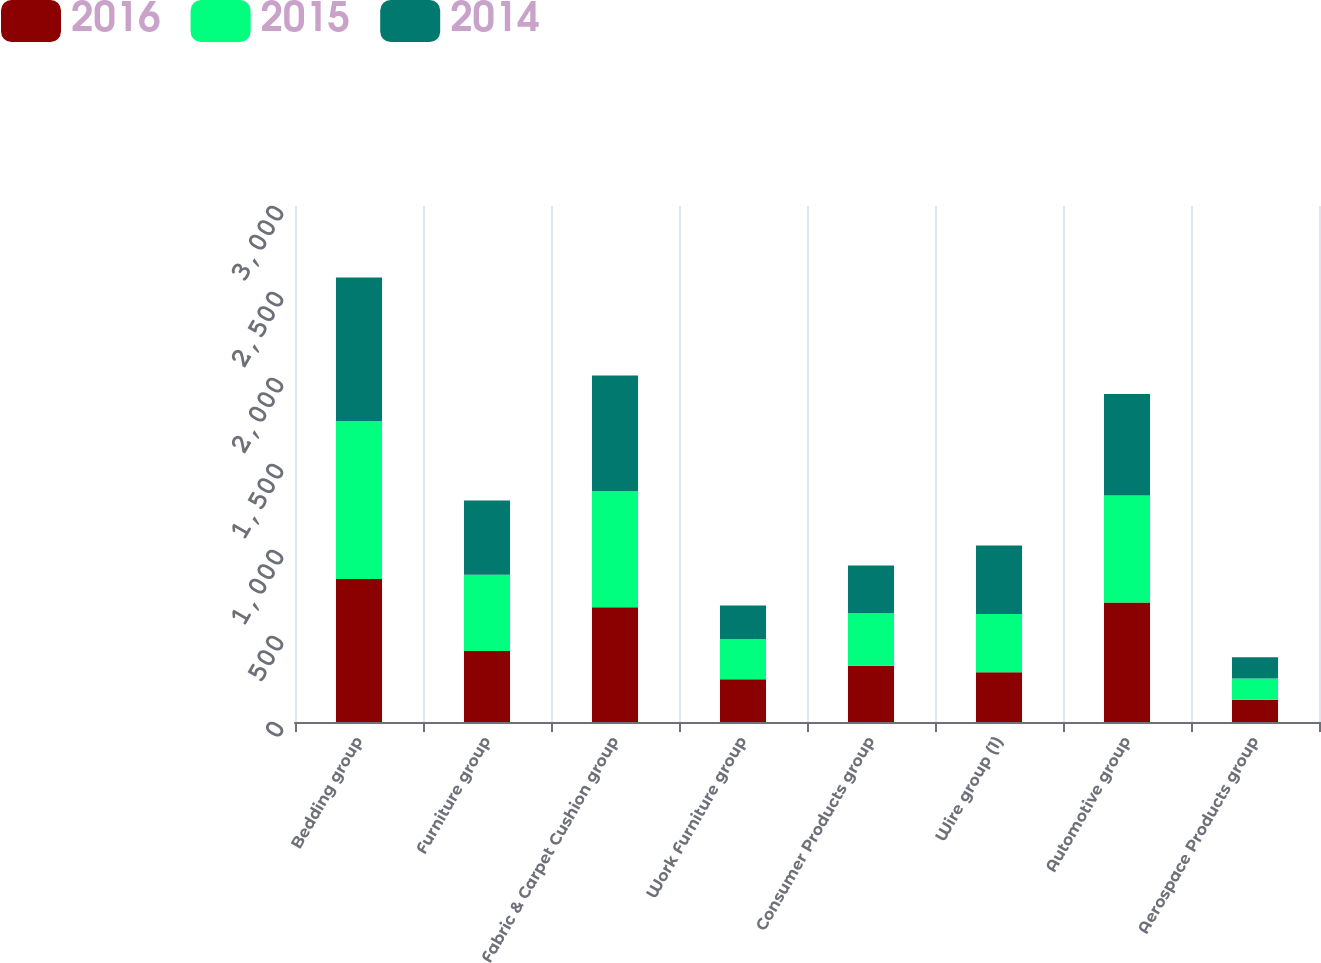<chart> <loc_0><loc_0><loc_500><loc_500><stacked_bar_chart><ecel><fcel>Bedding group<fcel>Furniture group<fcel>Fabric & Carpet Cushion group<fcel>Work Furniture group<fcel>Consumer Products group<fcel>Wire group (1)<fcel>Automotive group<fcel>Aerospace Products group<nl><fcel>2016<fcel>831.9<fcel>413.1<fcel>666.8<fcel>248.8<fcel>327.2<fcel>289.4<fcel>695.1<fcel>129.7<nl><fcel>2015<fcel>918.3<fcel>442.9<fcel>675<fcel>234.2<fcel>305.6<fcel>338.6<fcel>621.9<fcel>123.2<nl><fcel>2014<fcel>833.5<fcel>431.6<fcel>672.3<fcel>194.3<fcel>277.3<fcel>397.6<fcel>589.4<fcel>123.9<nl></chart> 